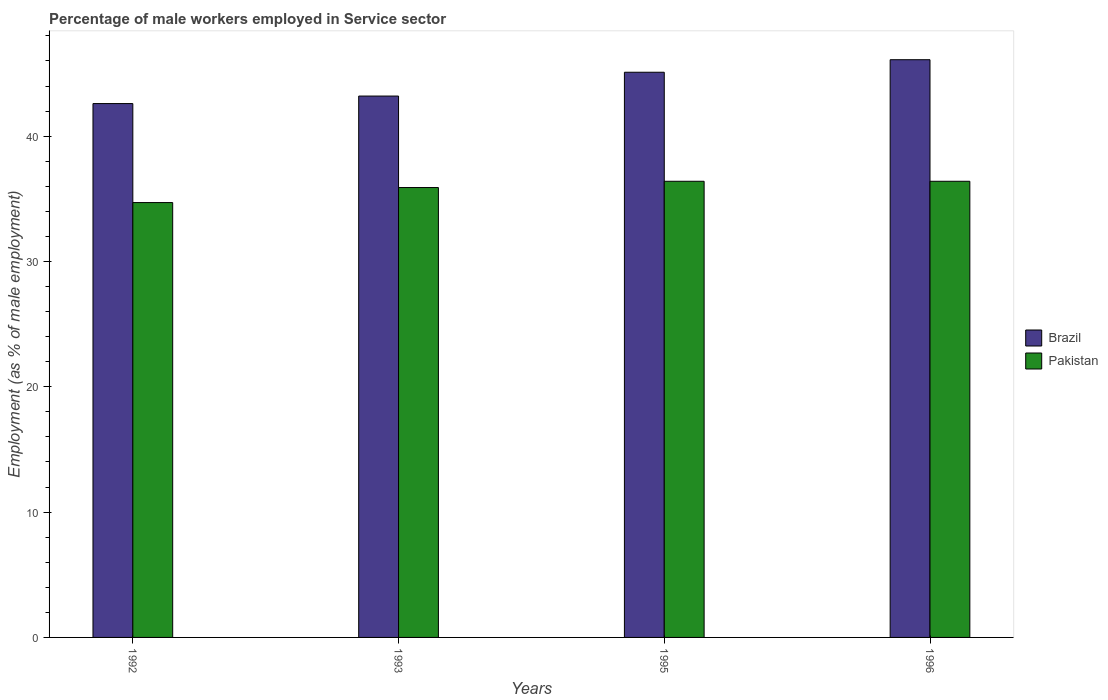Are the number of bars per tick equal to the number of legend labels?
Provide a succinct answer. Yes. Are the number of bars on each tick of the X-axis equal?
Offer a very short reply. Yes. How many bars are there on the 1st tick from the right?
Your response must be concise. 2. What is the label of the 3rd group of bars from the left?
Keep it short and to the point. 1995. In how many cases, is the number of bars for a given year not equal to the number of legend labels?
Keep it short and to the point. 0. What is the percentage of male workers employed in Service sector in Pakistan in 1993?
Offer a very short reply. 35.9. Across all years, what is the maximum percentage of male workers employed in Service sector in Pakistan?
Your answer should be compact. 36.4. Across all years, what is the minimum percentage of male workers employed in Service sector in Brazil?
Your response must be concise. 42.6. In which year was the percentage of male workers employed in Service sector in Brazil maximum?
Make the answer very short. 1996. In which year was the percentage of male workers employed in Service sector in Brazil minimum?
Provide a succinct answer. 1992. What is the total percentage of male workers employed in Service sector in Brazil in the graph?
Your response must be concise. 177. What is the difference between the percentage of male workers employed in Service sector in Pakistan in 1992 and the percentage of male workers employed in Service sector in Brazil in 1993?
Your answer should be compact. -8.5. What is the average percentage of male workers employed in Service sector in Pakistan per year?
Ensure brevity in your answer.  35.85. In the year 1992, what is the difference between the percentage of male workers employed in Service sector in Pakistan and percentage of male workers employed in Service sector in Brazil?
Provide a succinct answer. -7.9. What is the ratio of the percentage of male workers employed in Service sector in Brazil in 1995 to that in 1996?
Provide a succinct answer. 0.98. What is the difference between the highest and the lowest percentage of male workers employed in Service sector in Pakistan?
Provide a short and direct response. 1.7. What does the 2nd bar from the left in 1993 represents?
Your answer should be compact. Pakistan. Are the values on the major ticks of Y-axis written in scientific E-notation?
Provide a succinct answer. No. Where does the legend appear in the graph?
Offer a terse response. Center right. How many legend labels are there?
Offer a terse response. 2. What is the title of the graph?
Your answer should be compact. Percentage of male workers employed in Service sector. What is the label or title of the X-axis?
Make the answer very short. Years. What is the label or title of the Y-axis?
Your answer should be very brief. Employment (as % of male employment). What is the Employment (as % of male employment) of Brazil in 1992?
Give a very brief answer. 42.6. What is the Employment (as % of male employment) of Pakistan in 1992?
Keep it short and to the point. 34.7. What is the Employment (as % of male employment) of Brazil in 1993?
Your answer should be compact. 43.2. What is the Employment (as % of male employment) in Pakistan in 1993?
Your answer should be compact. 35.9. What is the Employment (as % of male employment) of Brazil in 1995?
Make the answer very short. 45.1. What is the Employment (as % of male employment) of Pakistan in 1995?
Offer a terse response. 36.4. What is the Employment (as % of male employment) of Brazil in 1996?
Provide a short and direct response. 46.1. What is the Employment (as % of male employment) in Pakistan in 1996?
Keep it short and to the point. 36.4. Across all years, what is the maximum Employment (as % of male employment) in Brazil?
Your answer should be very brief. 46.1. Across all years, what is the maximum Employment (as % of male employment) in Pakistan?
Give a very brief answer. 36.4. Across all years, what is the minimum Employment (as % of male employment) of Brazil?
Keep it short and to the point. 42.6. Across all years, what is the minimum Employment (as % of male employment) of Pakistan?
Give a very brief answer. 34.7. What is the total Employment (as % of male employment) of Brazil in the graph?
Provide a succinct answer. 177. What is the total Employment (as % of male employment) in Pakistan in the graph?
Your answer should be very brief. 143.4. What is the difference between the Employment (as % of male employment) of Brazil in 1992 and that in 1993?
Offer a terse response. -0.6. What is the difference between the Employment (as % of male employment) of Pakistan in 1992 and that in 1993?
Ensure brevity in your answer.  -1.2. What is the difference between the Employment (as % of male employment) in Brazil in 1992 and that in 1995?
Offer a very short reply. -2.5. What is the difference between the Employment (as % of male employment) of Pakistan in 1993 and that in 1995?
Your answer should be very brief. -0.5. What is the difference between the Employment (as % of male employment) in Brazil in 1993 and that in 1996?
Keep it short and to the point. -2.9. What is the difference between the Employment (as % of male employment) in Brazil in 1992 and the Employment (as % of male employment) in Pakistan in 1996?
Your response must be concise. 6.2. What is the difference between the Employment (as % of male employment) in Brazil in 1993 and the Employment (as % of male employment) in Pakistan in 1995?
Your answer should be compact. 6.8. What is the difference between the Employment (as % of male employment) of Brazil in 1995 and the Employment (as % of male employment) of Pakistan in 1996?
Your answer should be compact. 8.7. What is the average Employment (as % of male employment) in Brazil per year?
Provide a short and direct response. 44.25. What is the average Employment (as % of male employment) in Pakistan per year?
Provide a short and direct response. 35.85. In the year 1992, what is the difference between the Employment (as % of male employment) in Brazil and Employment (as % of male employment) in Pakistan?
Offer a very short reply. 7.9. In the year 1995, what is the difference between the Employment (as % of male employment) in Brazil and Employment (as % of male employment) in Pakistan?
Ensure brevity in your answer.  8.7. What is the ratio of the Employment (as % of male employment) of Brazil in 1992 to that in 1993?
Your response must be concise. 0.99. What is the ratio of the Employment (as % of male employment) of Pakistan in 1992 to that in 1993?
Provide a succinct answer. 0.97. What is the ratio of the Employment (as % of male employment) of Brazil in 1992 to that in 1995?
Keep it short and to the point. 0.94. What is the ratio of the Employment (as % of male employment) of Pakistan in 1992 to that in 1995?
Offer a very short reply. 0.95. What is the ratio of the Employment (as % of male employment) of Brazil in 1992 to that in 1996?
Your response must be concise. 0.92. What is the ratio of the Employment (as % of male employment) of Pakistan in 1992 to that in 1996?
Your answer should be very brief. 0.95. What is the ratio of the Employment (as % of male employment) of Brazil in 1993 to that in 1995?
Make the answer very short. 0.96. What is the ratio of the Employment (as % of male employment) of Pakistan in 1993 to that in 1995?
Your response must be concise. 0.99. What is the ratio of the Employment (as % of male employment) of Brazil in 1993 to that in 1996?
Provide a short and direct response. 0.94. What is the ratio of the Employment (as % of male employment) of Pakistan in 1993 to that in 1996?
Offer a very short reply. 0.99. What is the ratio of the Employment (as % of male employment) of Brazil in 1995 to that in 1996?
Give a very brief answer. 0.98. What is the ratio of the Employment (as % of male employment) of Pakistan in 1995 to that in 1996?
Provide a succinct answer. 1. What is the difference between the highest and the lowest Employment (as % of male employment) of Pakistan?
Your response must be concise. 1.7. 